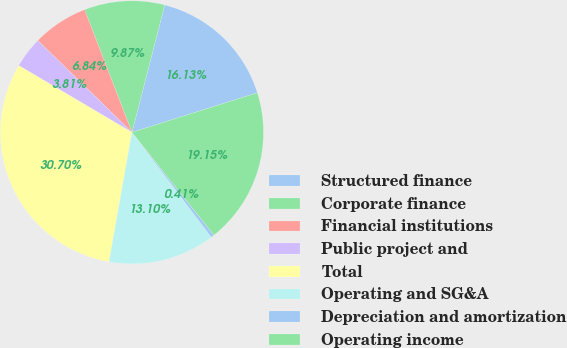Convert chart. <chart><loc_0><loc_0><loc_500><loc_500><pie_chart><fcel>Structured finance<fcel>Corporate finance<fcel>Financial institutions<fcel>Public project and<fcel>Total<fcel>Operating and SG&A<fcel>Depreciation and amortization<fcel>Operating income<nl><fcel>16.13%<fcel>9.87%<fcel>6.84%<fcel>3.81%<fcel>30.7%<fcel>13.1%<fcel>0.41%<fcel>19.15%<nl></chart> 